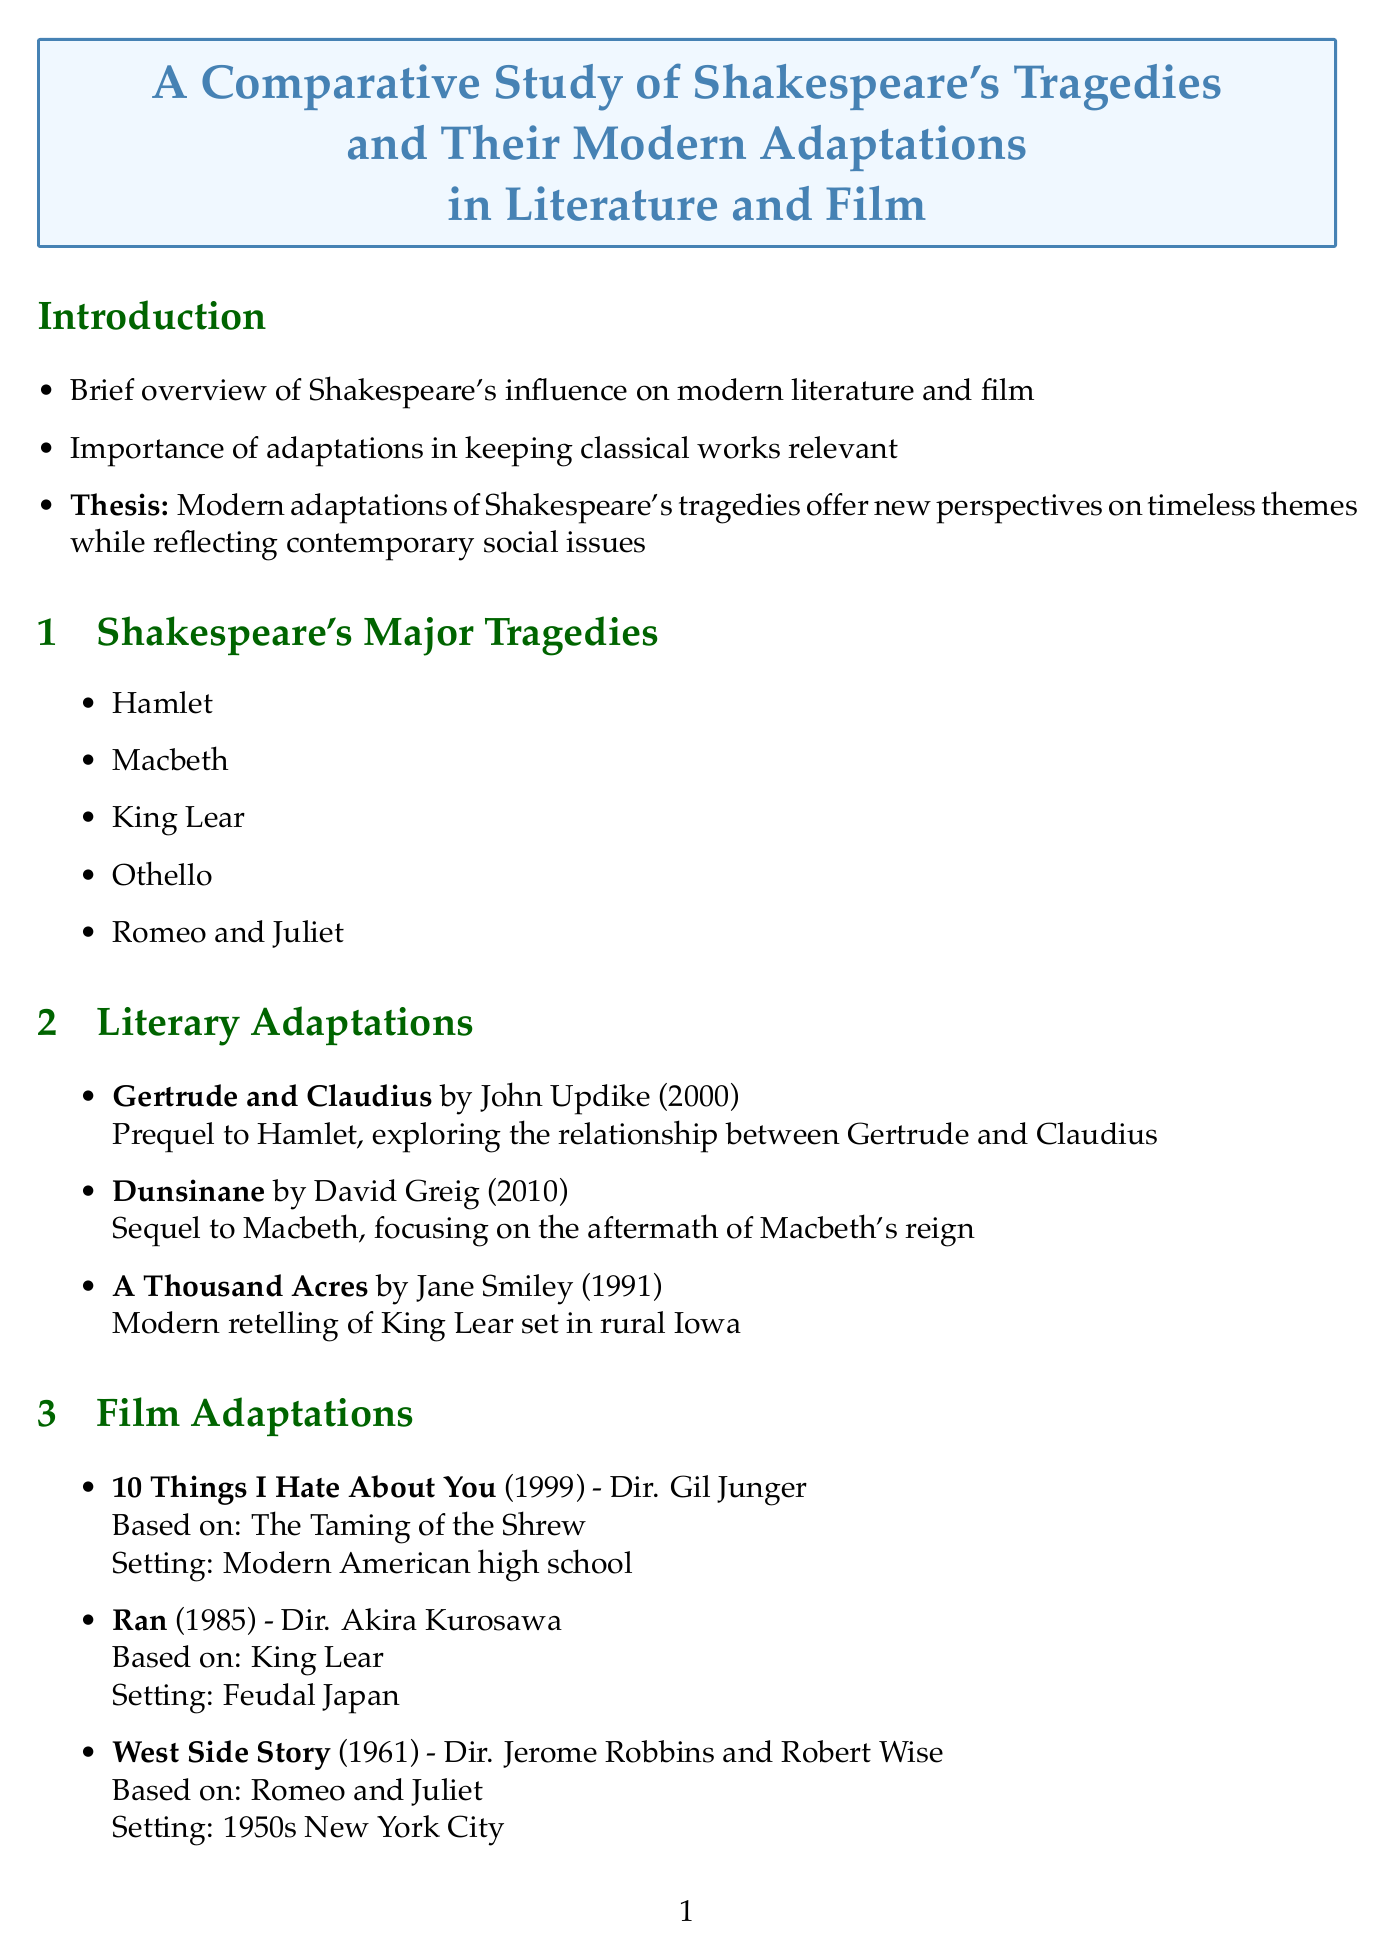What is the title of the study? The title of the study is found at the beginning of the document.
Answer: A Comparative Study of Shakespeare's Tragedies and Their Modern Adaptations in Literature and Film Who is the author of "Gertrude and Claudius"? This information is provided in the section about literary adaptations.
Answer: John Updike What year was "Dunsinane" published? The publication year is specified in the document under literary adaptations.
Answer: 2010 Name one modern adaptation of "Romeo and Juliet". The document lists several adaptations, one of which is noted in the film adaptations section.
Answer: West Side Story What is one theme explored in Hamlet related to bioengineering? This theme is outlined in the Bioengineering Connections section.
Answer: Mental health How do modern adaptations of Shakespeare's tragedies address issues? This reasoning can be derived from the Comparative Analysis section discussing thematic evolution.
Answer: Contemporary issues What narrative device is used to analyze character arcs? This technique is mentioned in the Literary Analysis Techniques section.
Answer: Character arc comparisons In what setting does "10 Things I Hate About You" take place? The setting is explicitly provided for this film adaptation in the document.
Answer: Modern American high school Which major tragedy is adapted in the film "Ran"? This information can be found in the Film Adaptations section.
Answer: King Lear 